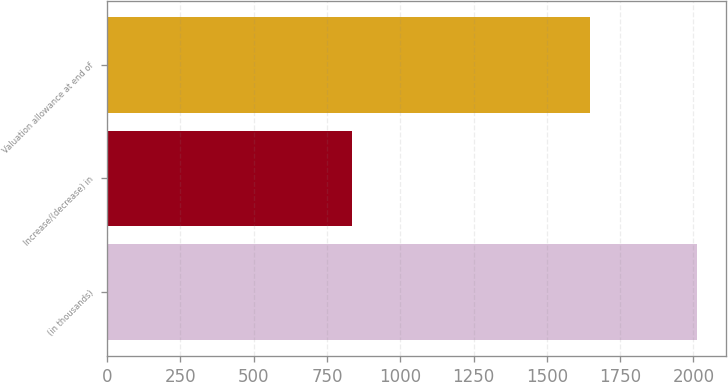Convert chart to OTSL. <chart><loc_0><loc_0><loc_500><loc_500><bar_chart><fcel>(in thousands)<fcel>Increase/(decrease) in<fcel>Valuation allowance at end of<nl><fcel>2011<fcel>836<fcel>1646<nl></chart> 